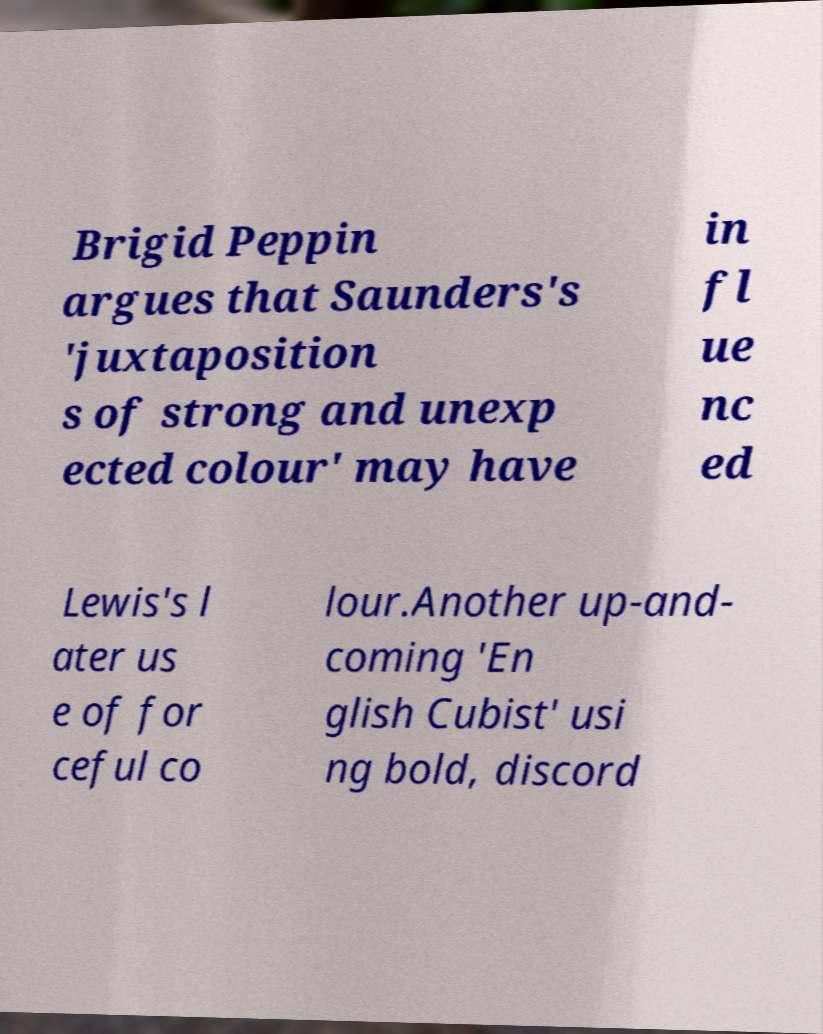Can you accurately transcribe the text from the provided image for me? Brigid Peppin argues that Saunders's 'juxtaposition s of strong and unexp ected colour' may have in fl ue nc ed Lewis's l ater us e of for ceful co lour.Another up-and- coming 'En glish Cubist' usi ng bold, discord 